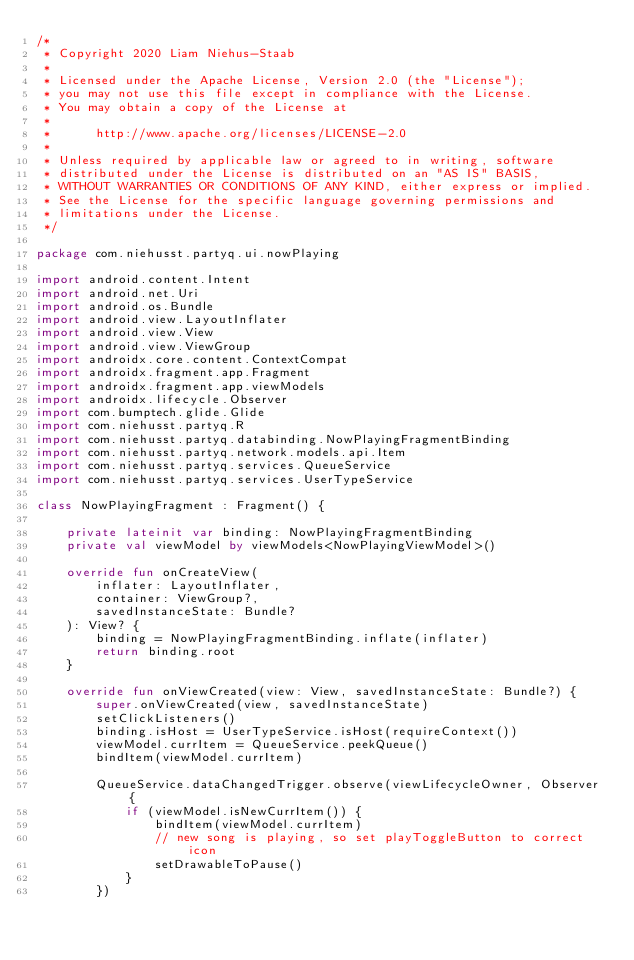<code> <loc_0><loc_0><loc_500><loc_500><_Kotlin_>/*
 * Copyright 2020 Liam Niehus-Staab
 *
 * Licensed under the Apache License, Version 2.0 (the "License");
 * you may not use this file except in compliance with the License.
 * You may obtain a copy of the License at
 *
 *      http://www.apache.org/licenses/LICENSE-2.0
 *
 * Unless required by applicable law or agreed to in writing, software
 * distributed under the License is distributed on an "AS IS" BASIS,
 * WITHOUT WARRANTIES OR CONDITIONS OF ANY KIND, either express or implied.
 * See the License for the specific language governing permissions and
 * limitations under the License.
 */

package com.niehusst.partyq.ui.nowPlaying

import android.content.Intent
import android.net.Uri
import android.os.Bundle
import android.view.LayoutInflater
import android.view.View
import android.view.ViewGroup
import androidx.core.content.ContextCompat
import androidx.fragment.app.Fragment
import androidx.fragment.app.viewModels
import androidx.lifecycle.Observer
import com.bumptech.glide.Glide
import com.niehusst.partyq.R
import com.niehusst.partyq.databinding.NowPlayingFragmentBinding
import com.niehusst.partyq.network.models.api.Item
import com.niehusst.partyq.services.QueueService
import com.niehusst.partyq.services.UserTypeService

class NowPlayingFragment : Fragment() {

    private lateinit var binding: NowPlayingFragmentBinding
    private val viewModel by viewModels<NowPlayingViewModel>()

    override fun onCreateView(
        inflater: LayoutInflater,
        container: ViewGroup?,
        savedInstanceState: Bundle?
    ): View? {
        binding = NowPlayingFragmentBinding.inflate(inflater)
        return binding.root
    }

    override fun onViewCreated(view: View, savedInstanceState: Bundle?) {
        super.onViewCreated(view, savedInstanceState)
        setClickListeners()
        binding.isHost = UserTypeService.isHost(requireContext())
        viewModel.currItem = QueueService.peekQueue()
        bindItem(viewModel.currItem)

        QueueService.dataChangedTrigger.observe(viewLifecycleOwner, Observer {
            if (viewModel.isNewCurrItem()) {
                bindItem(viewModel.currItem)
                // new song is playing, so set playToggleButton to correct icon
                setDrawableToPause()
            }
        })</code> 